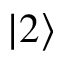Convert formula to latex. <formula><loc_0><loc_0><loc_500><loc_500>\left | 2 \right \rangle</formula> 